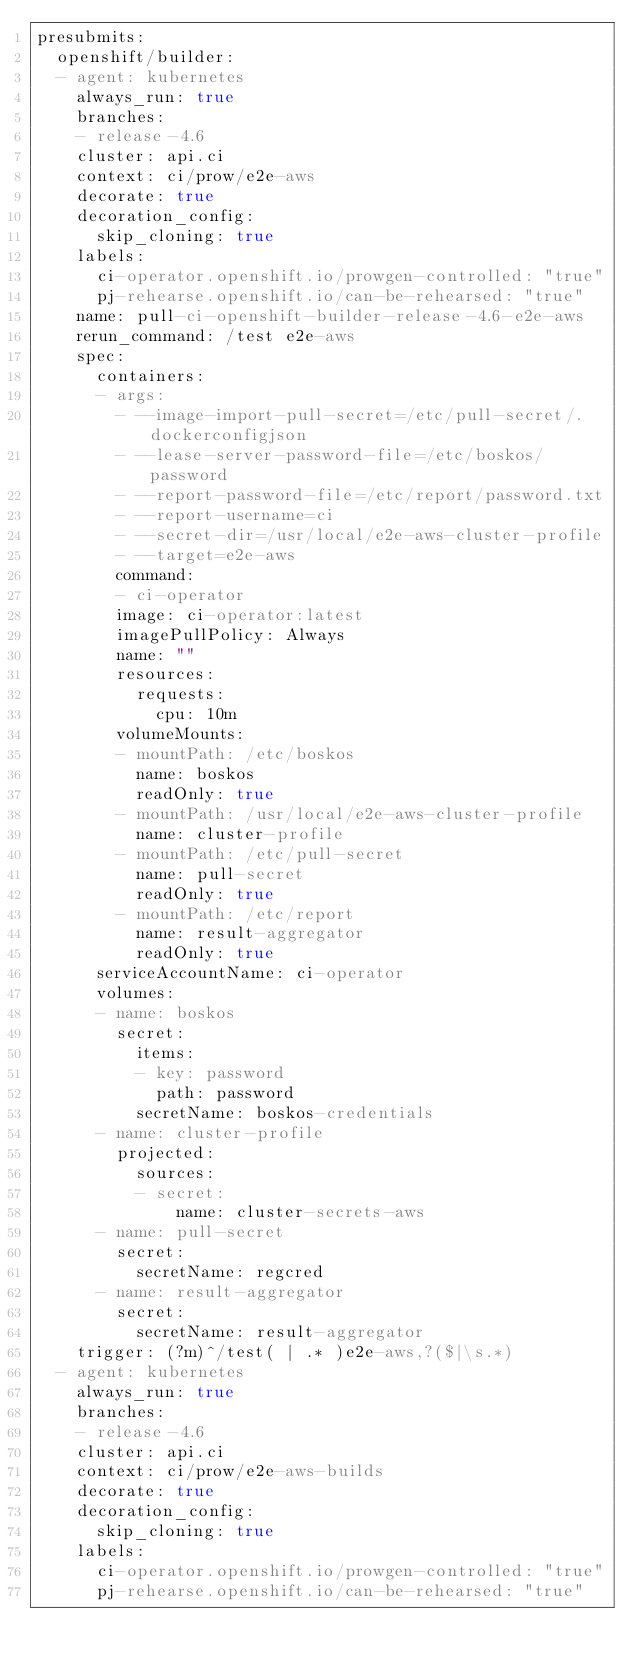<code> <loc_0><loc_0><loc_500><loc_500><_YAML_>presubmits:
  openshift/builder:
  - agent: kubernetes
    always_run: true
    branches:
    - release-4.6
    cluster: api.ci
    context: ci/prow/e2e-aws
    decorate: true
    decoration_config:
      skip_cloning: true
    labels:
      ci-operator.openshift.io/prowgen-controlled: "true"
      pj-rehearse.openshift.io/can-be-rehearsed: "true"
    name: pull-ci-openshift-builder-release-4.6-e2e-aws
    rerun_command: /test e2e-aws
    spec:
      containers:
      - args:
        - --image-import-pull-secret=/etc/pull-secret/.dockerconfigjson
        - --lease-server-password-file=/etc/boskos/password
        - --report-password-file=/etc/report/password.txt
        - --report-username=ci
        - --secret-dir=/usr/local/e2e-aws-cluster-profile
        - --target=e2e-aws
        command:
        - ci-operator
        image: ci-operator:latest
        imagePullPolicy: Always
        name: ""
        resources:
          requests:
            cpu: 10m
        volumeMounts:
        - mountPath: /etc/boskos
          name: boskos
          readOnly: true
        - mountPath: /usr/local/e2e-aws-cluster-profile
          name: cluster-profile
        - mountPath: /etc/pull-secret
          name: pull-secret
          readOnly: true
        - mountPath: /etc/report
          name: result-aggregator
          readOnly: true
      serviceAccountName: ci-operator
      volumes:
      - name: boskos
        secret:
          items:
          - key: password
            path: password
          secretName: boskos-credentials
      - name: cluster-profile
        projected:
          sources:
          - secret:
              name: cluster-secrets-aws
      - name: pull-secret
        secret:
          secretName: regcred
      - name: result-aggregator
        secret:
          secretName: result-aggregator
    trigger: (?m)^/test( | .* )e2e-aws,?($|\s.*)
  - agent: kubernetes
    always_run: true
    branches:
    - release-4.6
    cluster: api.ci
    context: ci/prow/e2e-aws-builds
    decorate: true
    decoration_config:
      skip_cloning: true
    labels:
      ci-operator.openshift.io/prowgen-controlled: "true"
      pj-rehearse.openshift.io/can-be-rehearsed: "true"</code> 